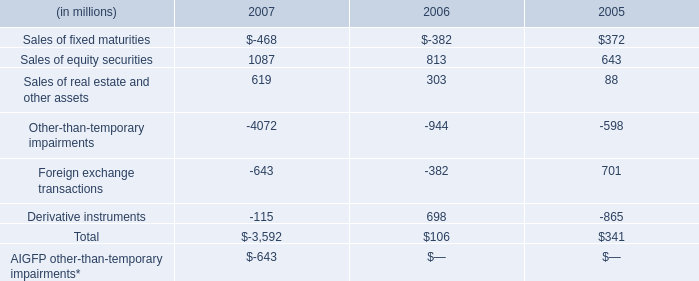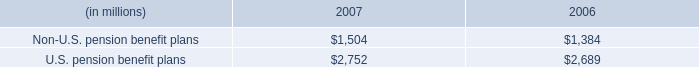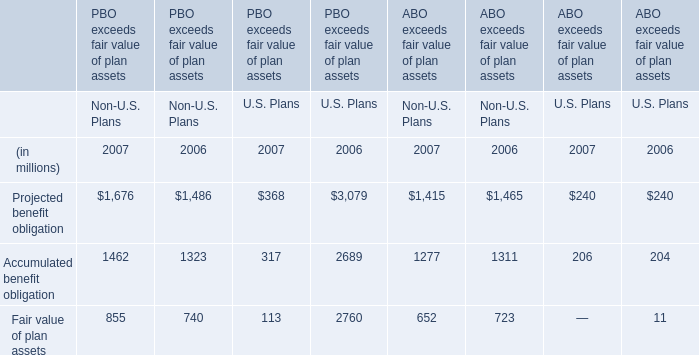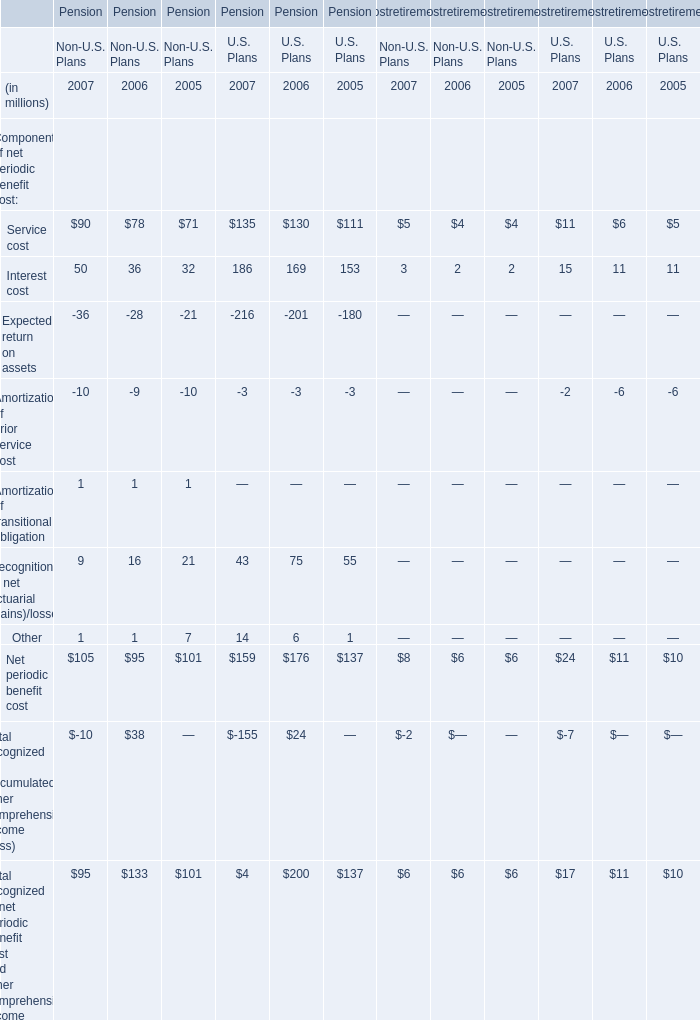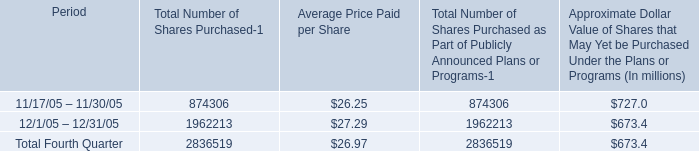what is the total amount of cash used for stock repurchase during december 2005 , in millions? 
Computations: ((1962213 * 27.29) / 1000000)
Answer: 53.54879. 